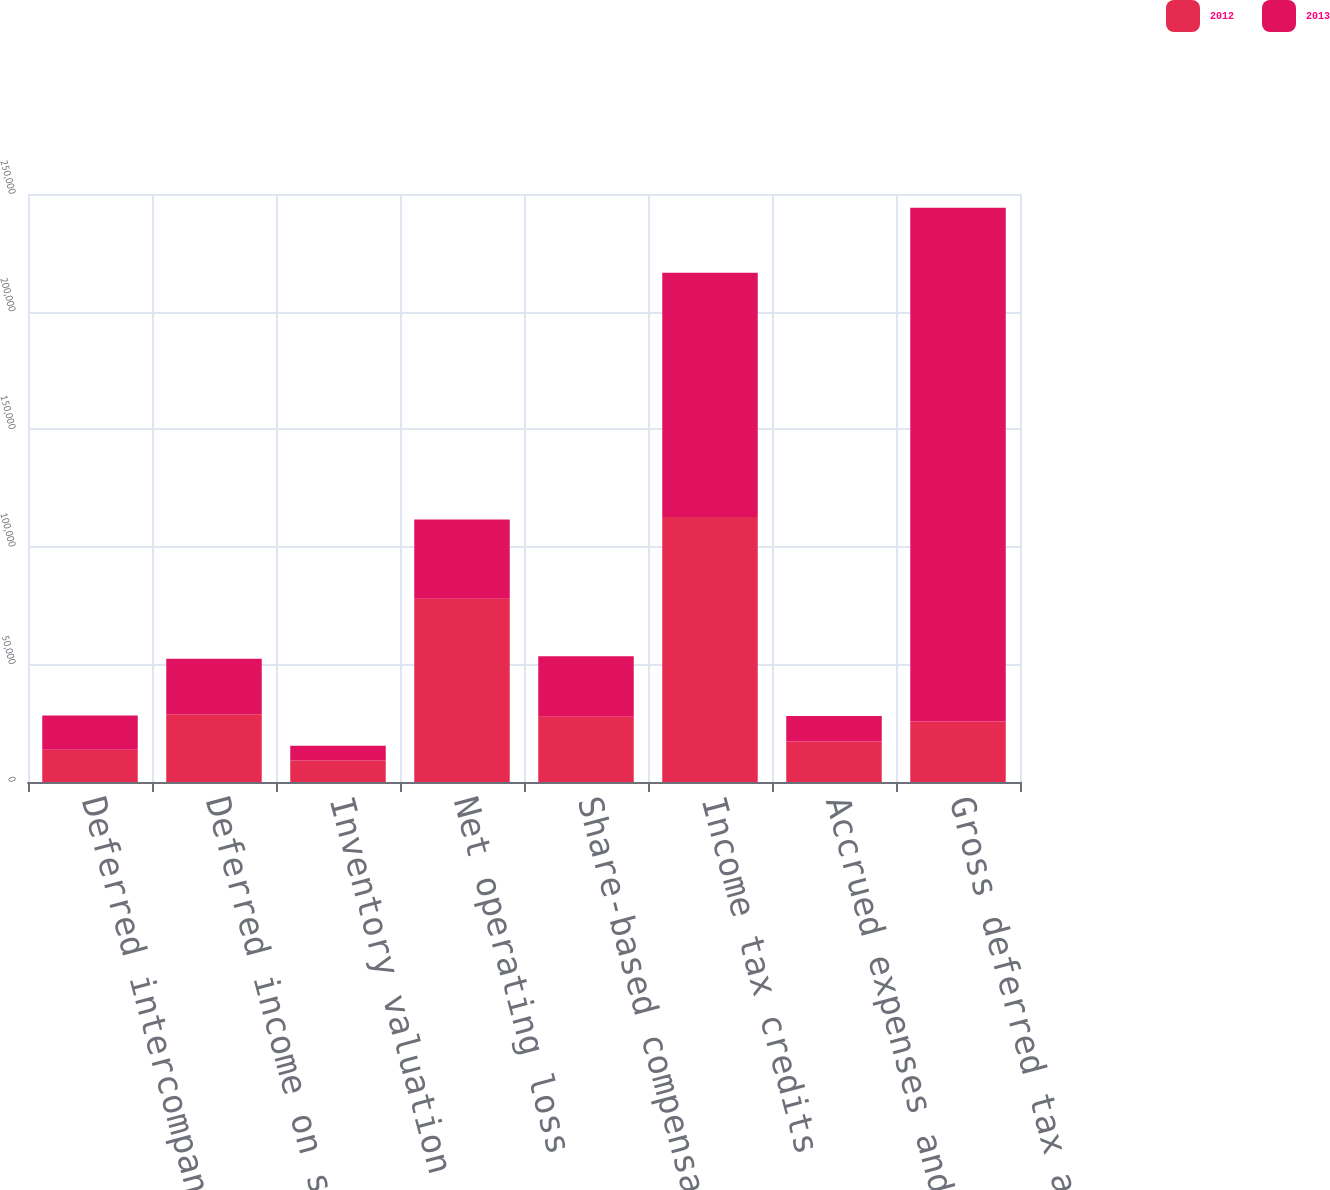<chart> <loc_0><loc_0><loc_500><loc_500><stacked_bar_chart><ecel><fcel>Deferred intercompany profit<fcel>Deferred income on shipments<fcel>Inventory valuation<fcel>Net operating loss<fcel>Share-based compensation<fcel>Income tax credits<fcel>Accrued expenses and other<fcel>Gross deferred tax assets<nl><fcel>2012<fcel>13679<fcel>28776<fcel>9148<fcel>77959<fcel>27757<fcel>112686<fcel>17241<fcel>25693<nl><fcel>2013<fcel>14624<fcel>23646<fcel>6245<fcel>33639<fcel>25693<fcel>103882<fcel>10770<fcel>218499<nl></chart> 